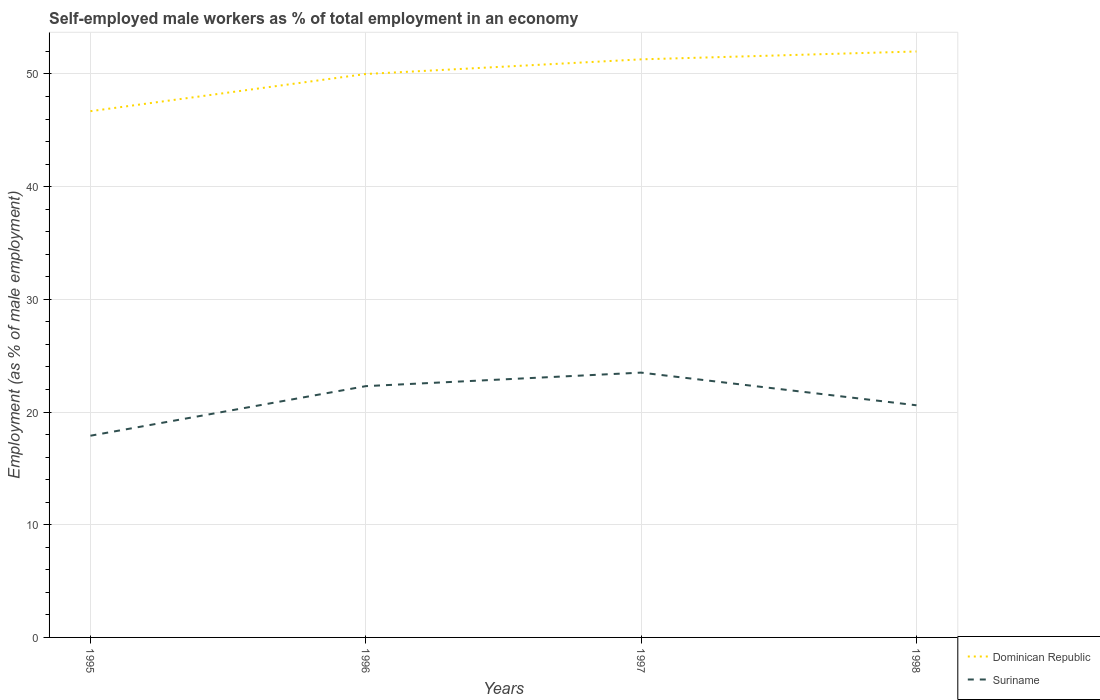How many different coloured lines are there?
Provide a short and direct response. 2. Is the number of lines equal to the number of legend labels?
Your answer should be compact. Yes. Across all years, what is the maximum percentage of self-employed male workers in Suriname?
Ensure brevity in your answer.  17.9. What is the total percentage of self-employed male workers in Suriname in the graph?
Offer a terse response. 2.9. What is the difference between the highest and the second highest percentage of self-employed male workers in Dominican Republic?
Offer a terse response. 5.3. How many lines are there?
Ensure brevity in your answer.  2. Does the graph contain grids?
Ensure brevity in your answer.  Yes. Where does the legend appear in the graph?
Keep it short and to the point. Bottom right. What is the title of the graph?
Provide a succinct answer. Self-employed male workers as % of total employment in an economy. What is the label or title of the X-axis?
Provide a short and direct response. Years. What is the label or title of the Y-axis?
Ensure brevity in your answer.  Employment (as % of male employment). What is the Employment (as % of male employment) of Dominican Republic in 1995?
Provide a succinct answer. 46.7. What is the Employment (as % of male employment) of Suriname in 1995?
Ensure brevity in your answer.  17.9. What is the Employment (as % of male employment) of Dominican Republic in 1996?
Offer a terse response. 50. What is the Employment (as % of male employment) of Suriname in 1996?
Provide a succinct answer. 22.3. What is the Employment (as % of male employment) of Dominican Republic in 1997?
Provide a succinct answer. 51.3. What is the Employment (as % of male employment) of Dominican Republic in 1998?
Your answer should be very brief. 52. What is the Employment (as % of male employment) of Suriname in 1998?
Give a very brief answer. 20.6. Across all years, what is the minimum Employment (as % of male employment) of Dominican Republic?
Keep it short and to the point. 46.7. Across all years, what is the minimum Employment (as % of male employment) of Suriname?
Offer a terse response. 17.9. What is the total Employment (as % of male employment) in Dominican Republic in the graph?
Provide a short and direct response. 200. What is the total Employment (as % of male employment) in Suriname in the graph?
Make the answer very short. 84.3. What is the difference between the Employment (as % of male employment) of Dominican Republic in 1995 and that in 1996?
Provide a succinct answer. -3.3. What is the difference between the Employment (as % of male employment) of Suriname in 1995 and that in 1996?
Provide a short and direct response. -4.4. What is the difference between the Employment (as % of male employment) of Suriname in 1995 and that in 1998?
Offer a terse response. -2.7. What is the difference between the Employment (as % of male employment) of Dominican Republic in 1997 and that in 1998?
Ensure brevity in your answer.  -0.7. What is the difference between the Employment (as % of male employment) of Suriname in 1997 and that in 1998?
Your answer should be very brief. 2.9. What is the difference between the Employment (as % of male employment) of Dominican Republic in 1995 and the Employment (as % of male employment) of Suriname in 1996?
Provide a succinct answer. 24.4. What is the difference between the Employment (as % of male employment) in Dominican Republic in 1995 and the Employment (as % of male employment) in Suriname in 1997?
Keep it short and to the point. 23.2. What is the difference between the Employment (as % of male employment) in Dominican Republic in 1995 and the Employment (as % of male employment) in Suriname in 1998?
Make the answer very short. 26.1. What is the difference between the Employment (as % of male employment) in Dominican Republic in 1996 and the Employment (as % of male employment) in Suriname in 1997?
Your response must be concise. 26.5. What is the difference between the Employment (as % of male employment) of Dominican Republic in 1996 and the Employment (as % of male employment) of Suriname in 1998?
Your answer should be compact. 29.4. What is the difference between the Employment (as % of male employment) of Dominican Republic in 1997 and the Employment (as % of male employment) of Suriname in 1998?
Provide a short and direct response. 30.7. What is the average Employment (as % of male employment) of Suriname per year?
Keep it short and to the point. 21.07. In the year 1995, what is the difference between the Employment (as % of male employment) of Dominican Republic and Employment (as % of male employment) of Suriname?
Your answer should be compact. 28.8. In the year 1996, what is the difference between the Employment (as % of male employment) of Dominican Republic and Employment (as % of male employment) of Suriname?
Offer a terse response. 27.7. In the year 1997, what is the difference between the Employment (as % of male employment) in Dominican Republic and Employment (as % of male employment) in Suriname?
Ensure brevity in your answer.  27.8. In the year 1998, what is the difference between the Employment (as % of male employment) of Dominican Republic and Employment (as % of male employment) of Suriname?
Give a very brief answer. 31.4. What is the ratio of the Employment (as % of male employment) in Dominican Republic in 1995 to that in 1996?
Your answer should be compact. 0.93. What is the ratio of the Employment (as % of male employment) of Suriname in 1995 to that in 1996?
Provide a short and direct response. 0.8. What is the ratio of the Employment (as % of male employment) in Dominican Republic in 1995 to that in 1997?
Keep it short and to the point. 0.91. What is the ratio of the Employment (as % of male employment) of Suriname in 1995 to that in 1997?
Offer a terse response. 0.76. What is the ratio of the Employment (as % of male employment) in Dominican Republic in 1995 to that in 1998?
Ensure brevity in your answer.  0.9. What is the ratio of the Employment (as % of male employment) in Suriname in 1995 to that in 1998?
Your answer should be compact. 0.87. What is the ratio of the Employment (as % of male employment) of Dominican Republic in 1996 to that in 1997?
Your response must be concise. 0.97. What is the ratio of the Employment (as % of male employment) of Suriname in 1996 to that in 1997?
Offer a very short reply. 0.95. What is the ratio of the Employment (as % of male employment) in Dominican Republic in 1996 to that in 1998?
Give a very brief answer. 0.96. What is the ratio of the Employment (as % of male employment) of Suriname in 1996 to that in 1998?
Offer a very short reply. 1.08. What is the ratio of the Employment (as % of male employment) in Dominican Republic in 1997 to that in 1998?
Offer a terse response. 0.99. What is the ratio of the Employment (as % of male employment) in Suriname in 1997 to that in 1998?
Provide a succinct answer. 1.14. What is the difference between the highest and the second highest Employment (as % of male employment) in Dominican Republic?
Provide a succinct answer. 0.7. What is the difference between the highest and the lowest Employment (as % of male employment) of Suriname?
Ensure brevity in your answer.  5.6. 